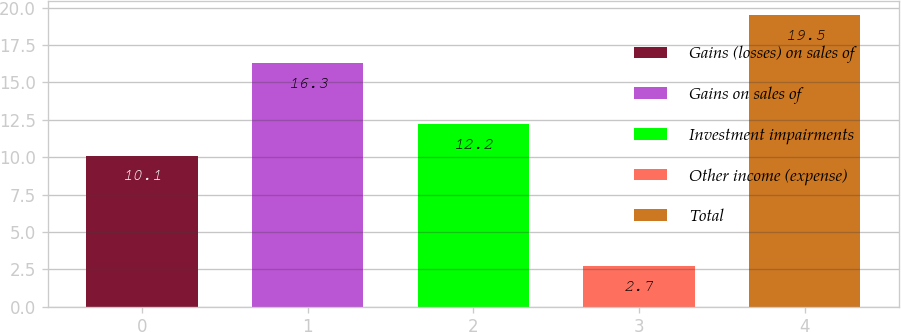Convert chart. <chart><loc_0><loc_0><loc_500><loc_500><bar_chart><fcel>Gains (losses) on sales of<fcel>Gains on sales of<fcel>Investment impairments<fcel>Other income (expense)<fcel>Total<nl><fcel>10.1<fcel>16.3<fcel>12.2<fcel>2.7<fcel>19.5<nl></chart> 